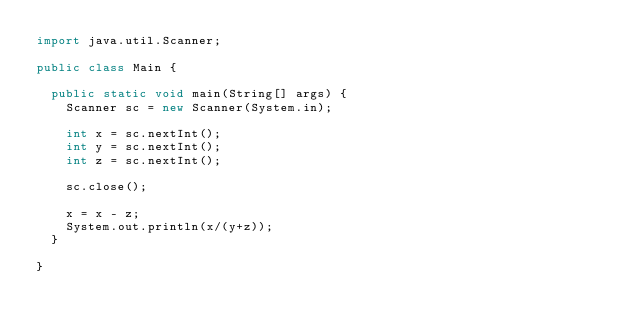<code> <loc_0><loc_0><loc_500><loc_500><_Java_>import java.util.Scanner;

public class Main {
	
	public static void main(String[] args) {
		Scanner sc = new Scanner(System.in);
		
		int x = sc.nextInt();
		int y = sc.nextInt();
		int z = sc.nextInt();
		
		sc.close();
		
		x = x - z;
		System.out.println(x/(y+z));
	}

}
</code> 